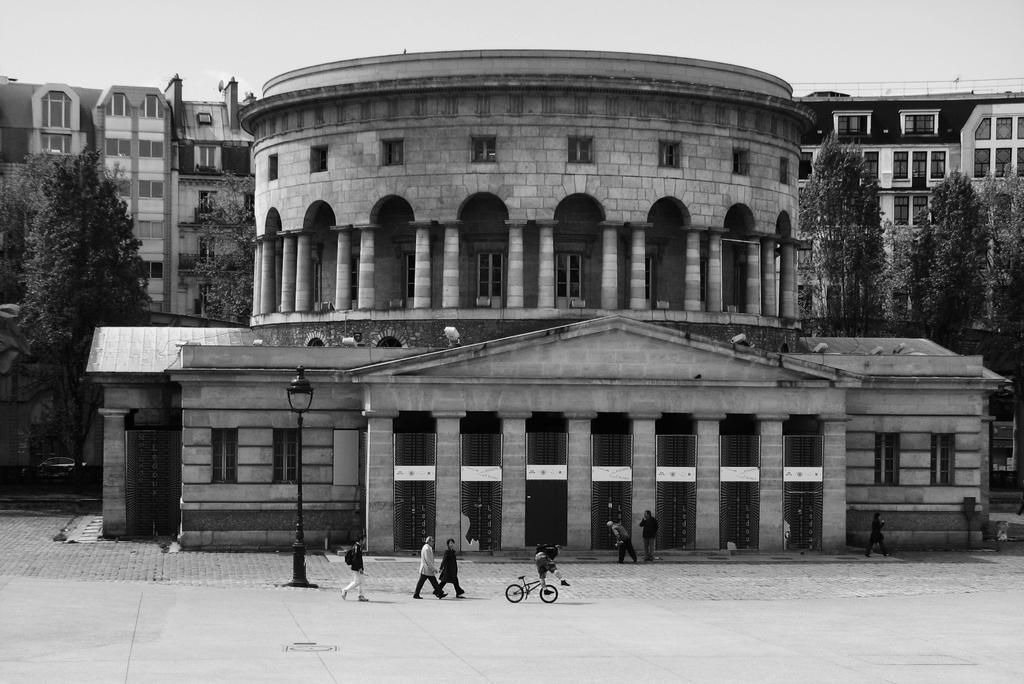Please provide a concise description of this image. This image is a black and white image. there are some persons standing at bottom of this image. The person standing in middle of this image is holding a backpack and there is a bicycle , and there is a building in the background. There are some trees on the left side of this image and on the right side of this image ,and there is a sky at top of this image and there is a pole at bottom left side of this image. 